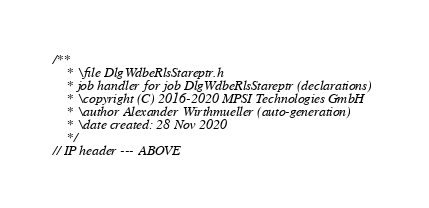Convert code to text. <code><loc_0><loc_0><loc_500><loc_500><_C_>/**
	* \file DlgWdbeRlsStareptr.h
	* job handler for job DlgWdbeRlsStareptr (declarations)
	* \copyright (C) 2016-2020 MPSI Technologies GmbH
	* \author Alexander Wirthmueller (auto-generation)
	* \date created: 28 Nov 2020
	*/
// IP header --- ABOVE
</code> 